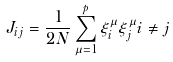Convert formula to latex. <formula><loc_0><loc_0><loc_500><loc_500>J _ { i j } = \frac { 1 } { 2 N } \sum _ { \mu = 1 } ^ { p } \xi _ { i } ^ { \mu } \xi _ { j } ^ { \mu } i \neq j</formula> 